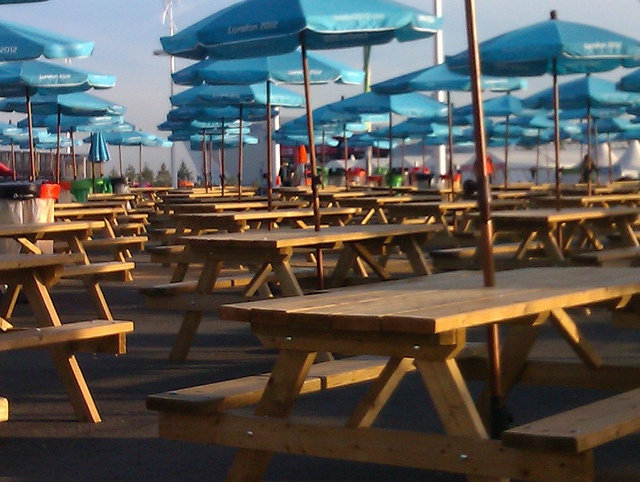Describe the objects in this image and their specific colors. I can see dining table in blue, black, maroon, tan, and gray tones, dining table in blue, black, maroon, and gray tones, umbrella in blue, darkblue, and lightblue tones, umbrella in blue, teal, and darkblue tones, and dining table in blue, black, gray, and maroon tones in this image. 